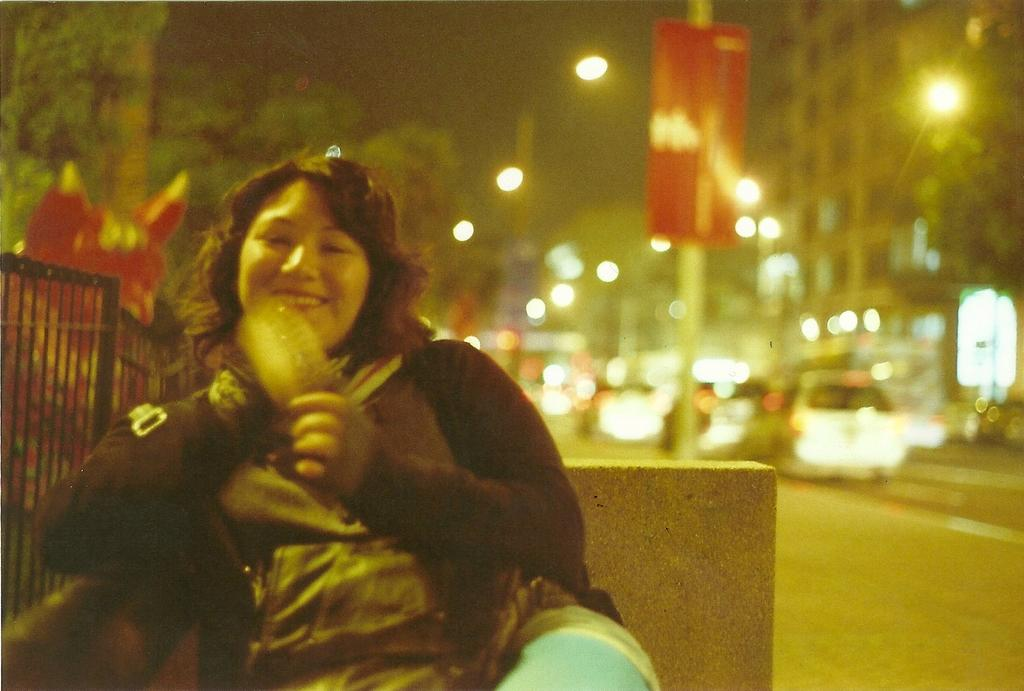What is the person in the image doing? The person is sitting on a bench in the image. What can be seen in the background of the image? In the background of the image, there are cars, poles, buildings, street lights, trees, and the sky. Can you describe the setting of the image? The image appears to be set in an urban environment, with buildings, cars, and street lights visible in the background. What type of lipstick is the kitten wearing in the image? There is no kitten or lipstick present in the image. What scientific discovery is being made in the image? There is no scientific discovery being made in the image; it simply shows a person sitting on a bench in an urban environment. 